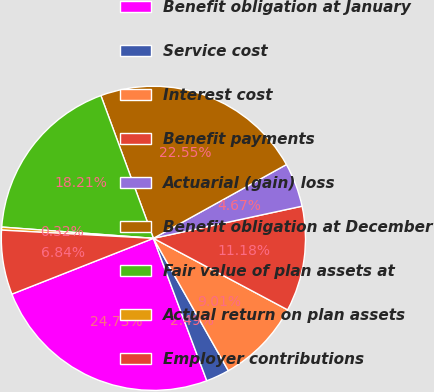<chart> <loc_0><loc_0><loc_500><loc_500><pie_chart><fcel>Benefit obligation at January<fcel>Service cost<fcel>Interest cost<fcel>Benefit payments<fcel>Actuarial (gain) loss<fcel>Benefit obligation at December<fcel>Fair value of plan assets at<fcel>Actual return on plan assets<fcel>Employer contributions<nl><fcel>24.73%<fcel>2.49%<fcel>9.01%<fcel>11.18%<fcel>4.67%<fcel>22.55%<fcel>18.21%<fcel>0.32%<fcel>6.84%<nl></chart> 